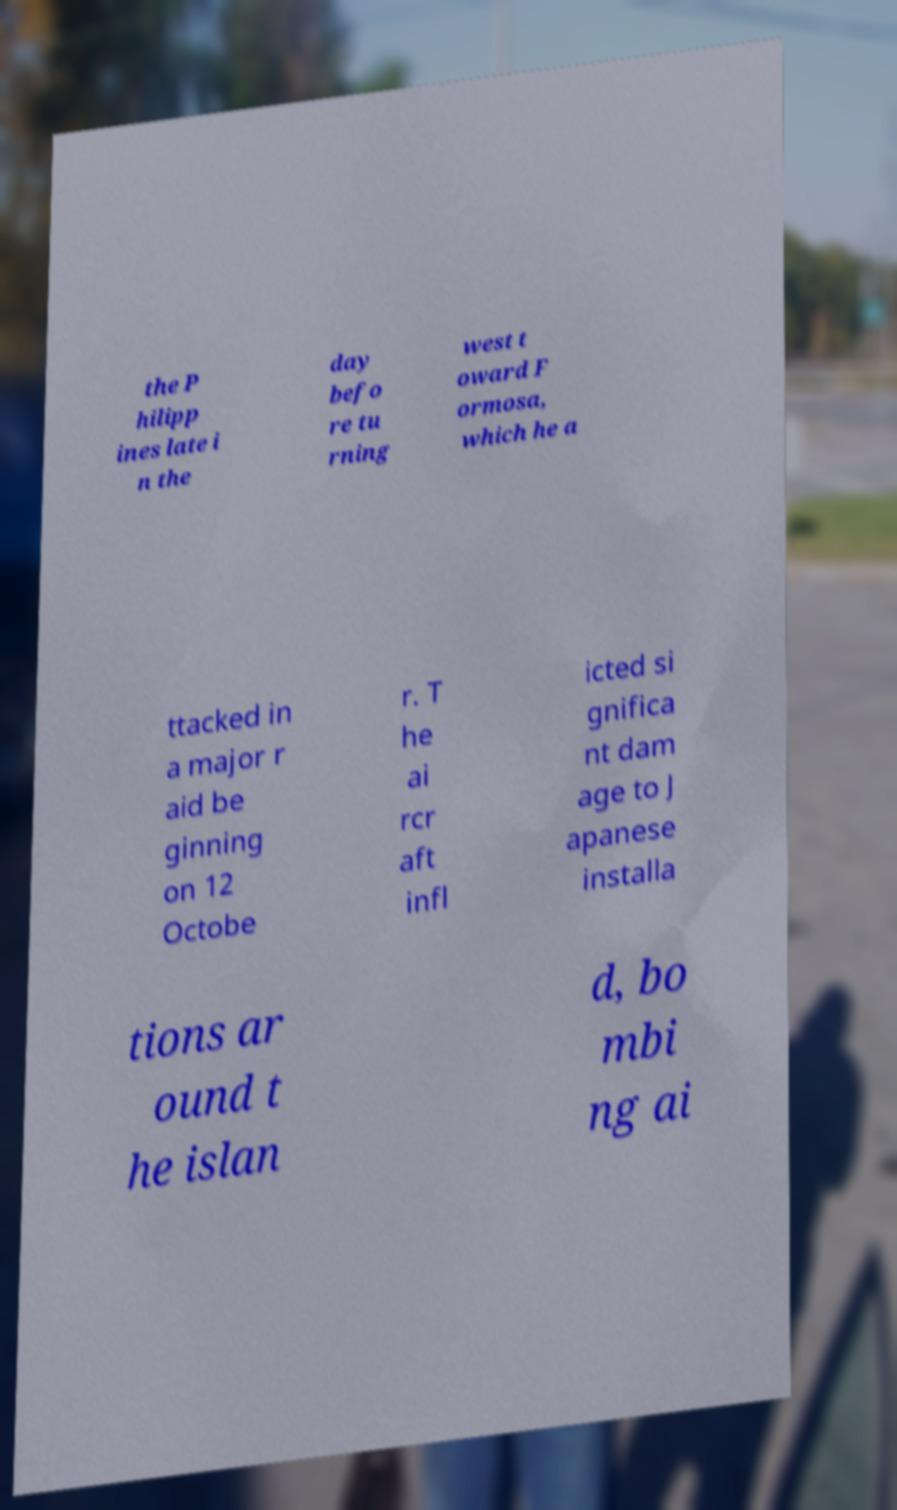Could you assist in decoding the text presented in this image and type it out clearly? the P hilipp ines late i n the day befo re tu rning west t oward F ormosa, which he a ttacked in a major r aid be ginning on 12 Octobe r. T he ai rcr aft infl icted si gnifica nt dam age to J apanese installa tions ar ound t he islan d, bo mbi ng ai 